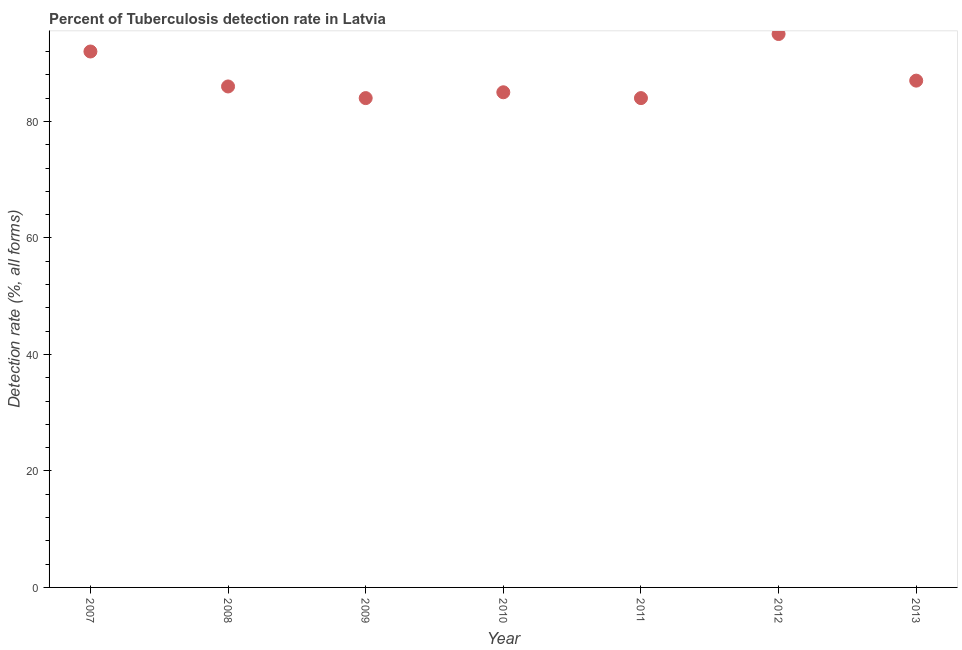What is the detection rate of tuberculosis in 2013?
Ensure brevity in your answer.  87. Across all years, what is the maximum detection rate of tuberculosis?
Your answer should be very brief. 95. Across all years, what is the minimum detection rate of tuberculosis?
Your answer should be compact. 84. In which year was the detection rate of tuberculosis maximum?
Ensure brevity in your answer.  2012. In which year was the detection rate of tuberculosis minimum?
Your response must be concise. 2009. What is the sum of the detection rate of tuberculosis?
Your response must be concise. 613. What is the difference between the detection rate of tuberculosis in 2011 and 2013?
Make the answer very short. -3. What is the average detection rate of tuberculosis per year?
Offer a very short reply. 87.57. In how many years, is the detection rate of tuberculosis greater than 56 %?
Your answer should be compact. 7. Do a majority of the years between 2012 and 2010 (inclusive) have detection rate of tuberculosis greater than 48 %?
Offer a terse response. No. What is the ratio of the detection rate of tuberculosis in 2007 to that in 2012?
Give a very brief answer. 0.97. Is the detection rate of tuberculosis in 2007 less than that in 2009?
Offer a very short reply. No. Is the difference between the detection rate of tuberculosis in 2009 and 2013 greater than the difference between any two years?
Provide a short and direct response. No. What is the difference between the highest and the second highest detection rate of tuberculosis?
Ensure brevity in your answer.  3. What is the difference between the highest and the lowest detection rate of tuberculosis?
Ensure brevity in your answer.  11. In how many years, is the detection rate of tuberculosis greater than the average detection rate of tuberculosis taken over all years?
Your answer should be very brief. 2. How many dotlines are there?
Keep it short and to the point. 1. What is the difference between two consecutive major ticks on the Y-axis?
Offer a terse response. 20. Are the values on the major ticks of Y-axis written in scientific E-notation?
Make the answer very short. No. What is the title of the graph?
Provide a short and direct response. Percent of Tuberculosis detection rate in Latvia. What is the label or title of the Y-axis?
Offer a very short reply. Detection rate (%, all forms). What is the Detection rate (%, all forms) in 2007?
Your answer should be very brief. 92. What is the Detection rate (%, all forms) in 2008?
Your answer should be very brief. 86. What is the Detection rate (%, all forms) in 2012?
Provide a short and direct response. 95. What is the Detection rate (%, all forms) in 2013?
Your answer should be very brief. 87. What is the difference between the Detection rate (%, all forms) in 2007 and 2008?
Provide a short and direct response. 6. What is the difference between the Detection rate (%, all forms) in 2007 and 2009?
Your answer should be very brief. 8. What is the difference between the Detection rate (%, all forms) in 2007 and 2013?
Your answer should be very brief. 5. What is the difference between the Detection rate (%, all forms) in 2008 and 2009?
Your answer should be very brief. 2. What is the difference between the Detection rate (%, all forms) in 2008 and 2010?
Your response must be concise. 1. What is the difference between the Detection rate (%, all forms) in 2008 and 2011?
Offer a very short reply. 2. What is the difference between the Detection rate (%, all forms) in 2008 and 2012?
Ensure brevity in your answer.  -9. What is the difference between the Detection rate (%, all forms) in 2008 and 2013?
Your response must be concise. -1. What is the difference between the Detection rate (%, all forms) in 2009 and 2010?
Offer a terse response. -1. What is the difference between the Detection rate (%, all forms) in 2009 and 2012?
Offer a terse response. -11. What is the difference between the Detection rate (%, all forms) in 2010 and 2012?
Offer a terse response. -10. What is the difference between the Detection rate (%, all forms) in 2010 and 2013?
Your answer should be compact. -2. What is the difference between the Detection rate (%, all forms) in 2011 and 2012?
Make the answer very short. -11. What is the ratio of the Detection rate (%, all forms) in 2007 to that in 2008?
Your answer should be compact. 1.07. What is the ratio of the Detection rate (%, all forms) in 2007 to that in 2009?
Provide a short and direct response. 1.09. What is the ratio of the Detection rate (%, all forms) in 2007 to that in 2010?
Ensure brevity in your answer.  1.08. What is the ratio of the Detection rate (%, all forms) in 2007 to that in 2011?
Offer a very short reply. 1.09. What is the ratio of the Detection rate (%, all forms) in 2007 to that in 2013?
Your answer should be compact. 1.06. What is the ratio of the Detection rate (%, all forms) in 2008 to that in 2010?
Your answer should be very brief. 1.01. What is the ratio of the Detection rate (%, all forms) in 2008 to that in 2011?
Provide a short and direct response. 1.02. What is the ratio of the Detection rate (%, all forms) in 2008 to that in 2012?
Offer a terse response. 0.91. What is the ratio of the Detection rate (%, all forms) in 2008 to that in 2013?
Make the answer very short. 0.99. What is the ratio of the Detection rate (%, all forms) in 2009 to that in 2010?
Your answer should be very brief. 0.99. What is the ratio of the Detection rate (%, all forms) in 2009 to that in 2011?
Make the answer very short. 1. What is the ratio of the Detection rate (%, all forms) in 2009 to that in 2012?
Offer a terse response. 0.88. What is the ratio of the Detection rate (%, all forms) in 2010 to that in 2011?
Give a very brief answer. 1.01. What is the ratio of the Detection rate (%, all forms) in 2010 to that in 2012?
Give a very brief answer. 0.9. What is the ratio of the Detection rate (%, all forms) in 2010 to that in 2013?
Make the answer very short. 0.98. What is the ratio of the Detection rate (%, all forms) in 2011 to that in 2012?
Provide a short and direct response. 0.88. What is the ratio of the Detection rate (%, all forms) in 2012 to that in 2013?
Provide a succinct answer. 1.09. 